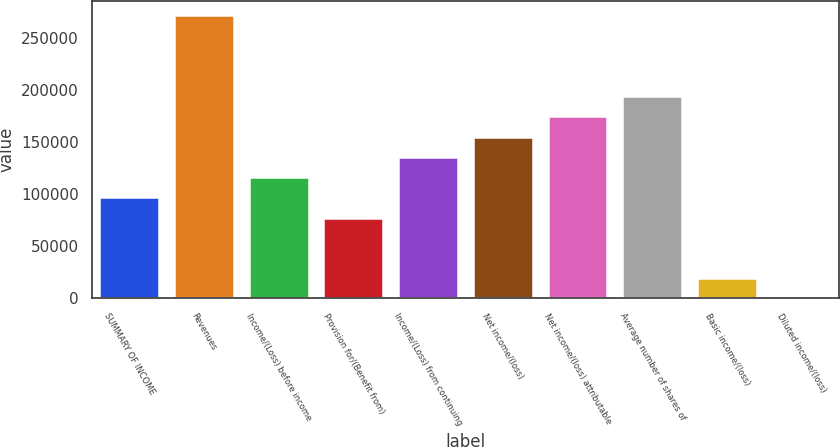Convert chart. <chart><loc_0><loc_0><loc_500><loc_500><bar_chart><fcel>SUMMARY OF INCOME<fcel>Revenues<fcel>Income/(Loss) before income<fcel>Provision for/(Benefit from)<fcel>Income/(Loss) from continuing<fcel>Net income/(loss)<fcel>Net income/(loss) attributable<fcel>Average number of shares of<fcel>Basic income/(loss)<fcel>Diluted income/(loss)<nl><fcel>96967.4<fcel>271507<fcel>116361<fcel>77574.1<fcel>135754<fcel>155147<fcel>174541<fcel>193934<fcel>19394.2<fcel>0.86<nl></chart> 